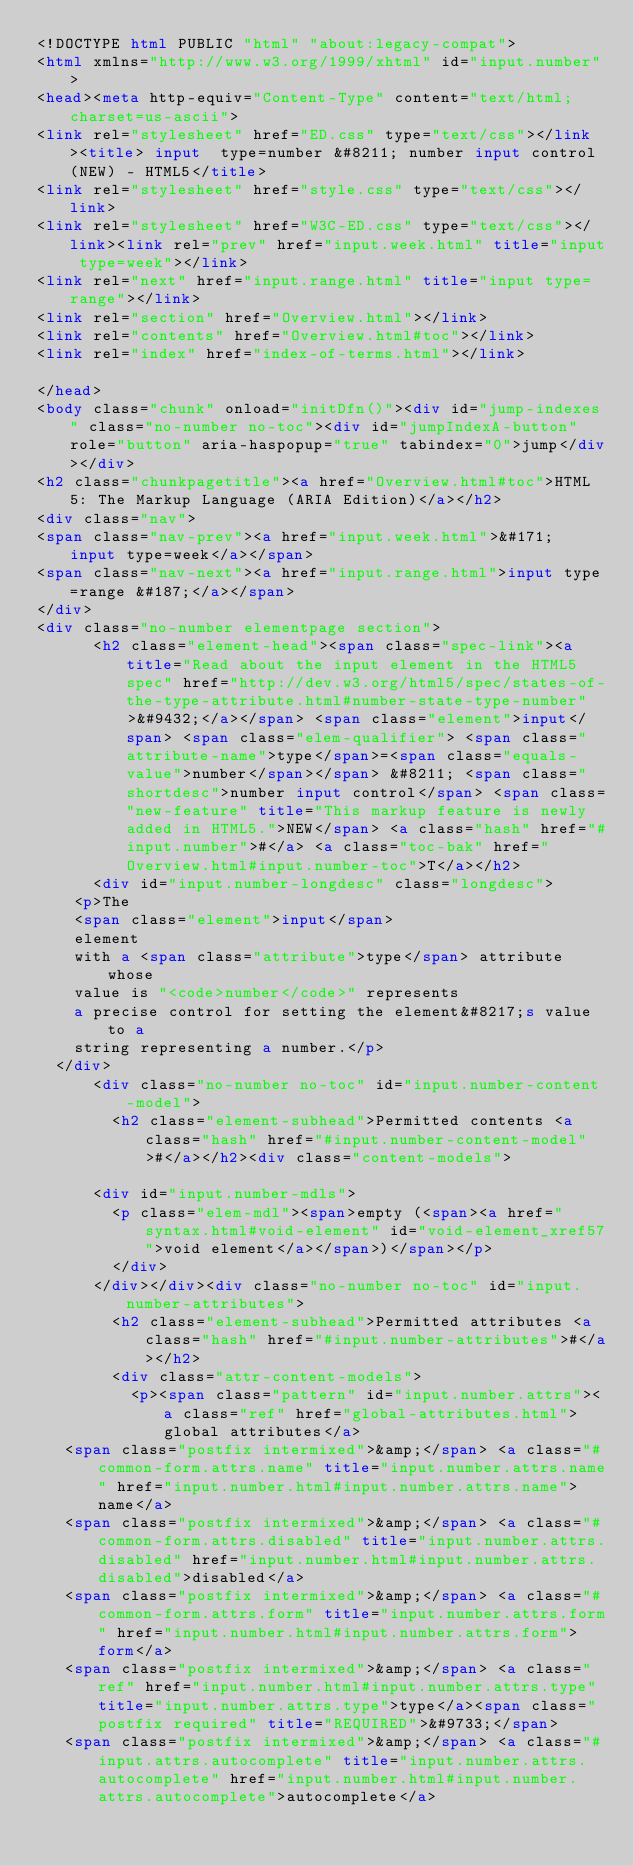<code> <loc_0><loc_0><loc_500><loc_500><_HTML_><!DOCTYPE html PUBLIC "html" "about:legacy-compat">
<html xmlns="http://www.w3.org/1999/xhtml" id="input.number">
<head><meta http-equiv="Content-Type" content="text/html; charset=us-ascii">
<link rel="stylesheet" href="ED.css" type="text/css"></link><title> input  type=number &#8211; number input control (NEW) - HTML5</title>
<link rel="stylesheet" href="style.css" type="text/css"></link>
<link rel="stylesheet" href="W3C-ED.css" type="text/css"></link><link rel="prev" href="input.week.html" title="input type=week"></link>
<link rel="next" href="input.range.html" title="input type=range"></link>
<link rel="section" href="Overview.html"></link>
<link rel="contents" href="Overview.html#toc"></link>
<link rel="index" href="index-of-terms.html"></link>

</head>
<body class="chunk" onload="initDfn()"><div id="jump-indexes" class="no-number no-toc"><div id="jumpIndexA-button" role="button" aria-haspopup="true" tabindex="0">jump</div></div>
<h2 class="chunkpagetitle"><a href="Overview.html#toc">HTML 5: The Markup Language (ARIA Edition)</a></h2>
<div class="nav">
<span class="nav-prev"><a href="input.week.html">&#171; input type=week</a></span>
<span class="nav-next"><a href="input.range.html">input type=range &#187;</a></span>
</div>
<div class="no-number elementpage section">
      <h2 class="element-head"><span class="spec-link"><a title="Read about the input element in the HTML5 spec" href="http://dev.w3.org/html5/spec/states-of-the-type-attribute.html#number-state-type-number">&#9432;</a></span> <span class="element">input</span> <span class="elem-qualifier"> <span class="attribute-name">type</span>=<span class="equals-value">number</span></span> &#8211; <span class="shortdesc">number input control</span> <span class="new-feature" title="This markup feature is newly added in HTML5.">NEW</span> <a class="hash" href="#input.number">#</a> <a class="toc-bak" href="Overview.html#input.number-toc">T</a></h2>
      <div id="input.number-longdesc" class="longdesc">
    <p>The
    <span class="element">input</span>
    element
    with a <span class="attribute">type</span> attribute whose
    value is "<code>number</code>" represents
    a precise control for setting the element&#8217;s value to a
    string representing a number.</p>
  </div>
      <div class="no-number no-toc" id="input.number-content-model">
        <h2 class="element-subhead">Permitted contents <a class="hash" href="#input.number-content-model">#</a></h2><div class="content-models">
        
      <div id="input.number-mdls">
        <p class="elem-mdl"><span>empty (<span><a href="syntax.html#void-element" id="void-element_xref57">void element</a></span>)</span></p>
        </div>
      </div></div><div class="no-number no-toc" id="input.number-attributes">
        <h2 class="element-subhead">Permitted attributes <a class="hash" href="#input.number-attributes">#</a></h2>
        <div class="attr-content-models">
          <p><span class="pattern" id="input.number.attrs"><a class="ref" href="global-attributes.html">global attributes</a>
   <span class="postfix intermixed">&amp;</span> <a class="#common-form.attrs.name" title="input.number.attrs.name" href="input.number.html#input.number.attrs.name">name</a> 
   <span class="postfix intermixed">&amp;</span> <a class="#common-form.attrs.disabled" title="input.number.attrs.disabled" href="input.number.html#input.number.attrs.disabled">disabled</a> 
   <span class="postfix intermixed">&amp;</span> <a class="#common-form.attrs.form" title="input.number.attrs.form" href="input.number.html#input.number.attrs.form">form</a> 
   <span class="postfix intermixed">&amp;</span> <a class="ref" href="input.number.html#input.number.attrs.type" title="input.number.attrs.type">type</a><span class="postfix required" title="REQUIRED">&#9733;</span>
   <span class="postfix intermixed">&amp;</span> <a class="#input.attrs.autocomplete" title="input.number.attrs.autocomplete" href="input.number.html#input.number.attrs.autocomplete">autocomplete</a> </code> 